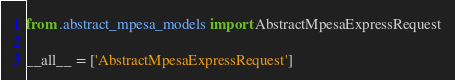Convert code to text. <code><loc_0><loc_0><loc_500><loc_500><_Python_>from .abstract_mpesa_models import AbstractMpesaExpressRequest

__all__ = ['AbstractMpesaExpressRequest']
</code> 